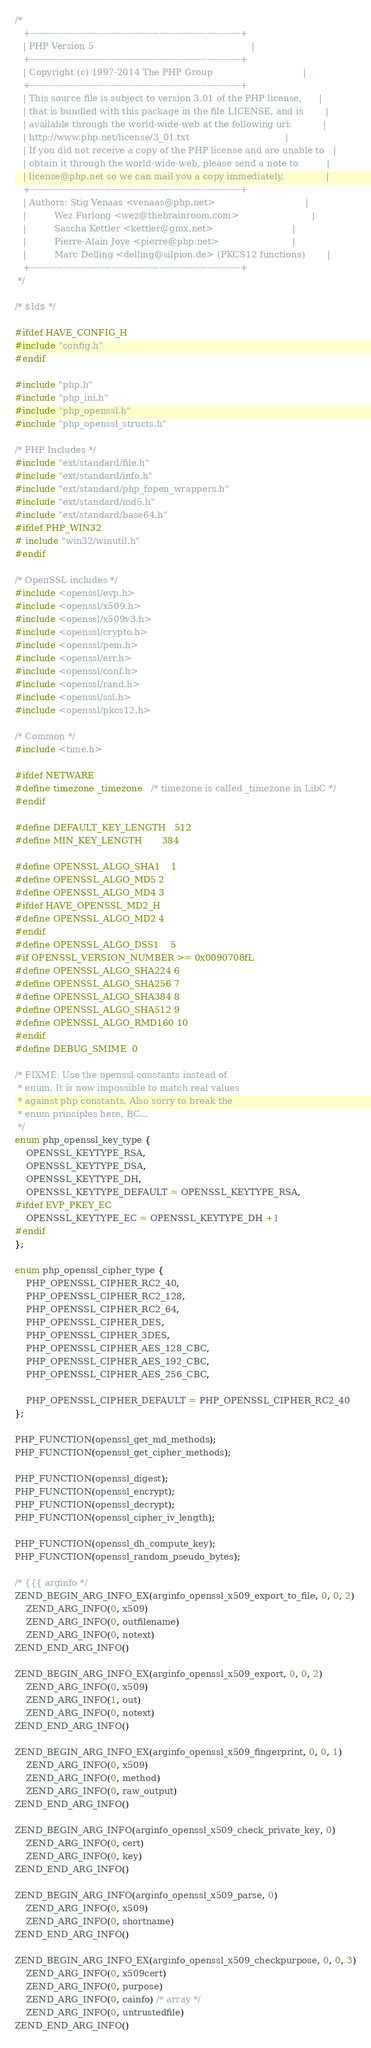Convert code to text. <code><loc_0><loc_0><loc_500><loc_500><_C_>/*
   +----------------------------------------------------------------------+
   | PHP Version 5                                                        |
   +----------------------------------------------------------------------+
   | Copyright (c) 1997-2014 The PHP Group                                |
   +----------------------------------------------------------------------+
   | This source file is subject to version 3.01 of the PHP license,      |
   | that is bundled with this package in the file LICENSE, and is        |
   | available through the world-wide-web at the following url:           |
   | http://www.php.net/license/3_01.txt                                  |
   | If you did not receive a copy of the PHP license and are unable to   |
   | obtain it through the world-wide-web, please send a note to          |
   | license@php.net so we can mail you a copy immediately.               |
   +----------------------------------------------------------------------+
   | Authors: Stig Venaas <venaas@php.net>                                |
   |          Wez Furlong <wez@thebrainroom.com>                          |
   |          Sascha Kettler <kettler@gmx.net>                            |
   |          Pierre-Alain Joye <pierre@php.net>                          |
   |          Marc Delling <delling@silpion.de> (PKCS12 functions)        |		
   +----------------------------------------------------------------------+
 */

/* $Id$ */

#ifdef HAVE_CONFIG_H
#include "config.h"
#endif

#include "php.h"
#include "php_ini.h"
#include "php_openssl.h"
#include "php_openssl_structs.h"

/* PHP Includes */
#include "ext/standard/file.h"
#include "ext/standard/info.h"
#include "ext/standard/php_fopen_wrappers.h"
#include "ext/standard/md5.h"
#include "ext/standard/base64.h"
#ifdef PHP_WIN32
# include "win32/winutil.h"
#endif

/* OpenSSL includes */
#include <openssl/evp.h>
#include <openssl/x509.h>
#include <openssl/x509v3.h>
#include <openssl/crypto.h>
#include <openssl/pem.h>
#include <openssl/err.h>
#include <openssl/conf.h>
#include <openssl/rand.h>
#include <openssl/ssl.h>
#include <openssl/pkcs12.h>

/* Common */
#include <time.h>

#ifdef NETWARE
#define timezone _timezone	/* timezone is called _timezone in LibC */
#endif

#define DEFAULT_KEY_LENGTH	512
#define MIN_KEY_LENGTH		384

#define OPENSSL_ALGO_SHA1 	1
#define OPENSSL_ALGO_MD5	2
#define OPENSSL_ALGO_MD4	3
#ifdef HAVE_OPENSSL_MD2_H
#define OPENSSL_ALGO_MD2	4
#endif
#define OPENSSL_ALGO_DSS1	5
#if OPENSSL_VERSION_NUMBER >= 0x0090708fL
#define OPENSSL_ALGO_SHA224 6
#define OPENSSL_ALGO_SHA256 7
#define OPENSSL_ALGO_SHA384 8
#define OPENSSL_ALGO_SHA512 9
#define OPENSSL_ALGO_RMD160 10
#endif
#define DEBUG_SMIME	0

/* FIXME: Use the openssl constants instead of
 * enum. It is now impossible to match real values
 * against php constants. Also sorry to break the
 * enum principles here, BC...
 */
enum php_openssl_key_type {
	OPENSSL_KEYTYPE_RSA,
	OPENSSL_KEYTYPE_DSA,
	OPENSSL_KEYTYPE_DH,
	OPENSSL_KEYTYPE_DEFAULT = OPENSSL_KEYTYPE_RSA,
#ifdef EVP_PKEY_EC
	OPENSSL_KEYTYPE_EC = OPENSSL_KEYTYPE_DH +1
#endif
};

enum php_openssl_cipher_type {
	PHP_OPENSSL_CIPHER_RC2_40,
	PHP_OPENSSL_CIPHER_RC2_128,
	PHP_OPENSSL_CIPHER_RC2_64,
	PHP_OPENSSL_CIPHER_DES,
	PHP_OPENSSL_CIPHER_3DES,
	PHP_OPENSSL_CIPHER_AES_128_CBC,
	PHP_OPENSSL_CIPHER_AES_192_CBC,
	PHP_OPENSSL_CIPHER_AES_256_CBC,

	PHP_OPENSSL_CIPHER_DEFAULT = PHP_OPENSSL_CIPHER_RC2_40
};

PHP_FUNCTION(openssl_get_md_methods);
PHP_FUNCTION(openssl_get_cipher_methods);

PHP_FUNCTION(openssl_digest);
PHP_FUNCTION(openssl_encrypt);
PHP_FUNCTION(openssl_decrypt);
PHP_FUNCTION(openssl_cipher_iv_length);

PHP_FUNCTION(openssl_dh_compute_key);
PHP_FUNCTION(openssl_random_pseudo_bytes);

/* {{{ arginfo */
ZEND_BEGIN_ARG_INFO_EX(arginfo_openssl_x509_export_to_file, 0, 0, 2)
    ZEND_ARG_INFO(0, x509)
    ZEND_ARG_INFO(0, outfilename)
    ZEND_ARG_INFO(0, notext)
ZEND_END_ARG_INFO()

ZEND_BEGIN_ARG_INFO_EX(arginfo_openssl_x509_export, 0, 0, 2)
    ZEND_ARG_INFO(0, x509)
    ZEND_ARG_INFO(1, out)
    ZEND_ARG_INFO(0, notext)
ZEND_END_ARG_INFO()

ZEND_BEGIN_ARG_INFO_EX(arginfo_openssl_x509_fingerprint, 0, 0, 1)
	ZEND_ARG_INFO(0, x509)
	ZEND_ARG_INFO(0, method)
	ZEND_ARG_INFO(0, raw_output)
ZEND_END_ARG_INFO()

ZEND_BEGIN_ARG_INFO(arginfo_openssl_x509_check_private_key, 0)
    ZEND_ARG_INFO(0, cert)
    ZEND_ARG_INFO(0, key)
ZEND_END_ARG_INFO()

ZEND_BEGIN_ARG_INFO(arginfo_openssl_x509_parse, 0)
    ZEND_ARG_INFO(0, x509)
    ZEND_ARG_INFO(0, shortname)
ZEND_END_ARG_INFO()

ZEND_BEGIN_ARG_INFO_EX(arginfo_openssl_x509_checkpurpose, 0, 0, 3)
    ZEND_ARG_INFO(0, x509cert)
    ZEND_ARG_INFO(0, purpose)
    ZEND_ARG_INFO(0, cainfo) /* array */
    ZEND_ARG_INFO(0, untrustedfile)
ZEND_END_ARG_INFO()
</code> 